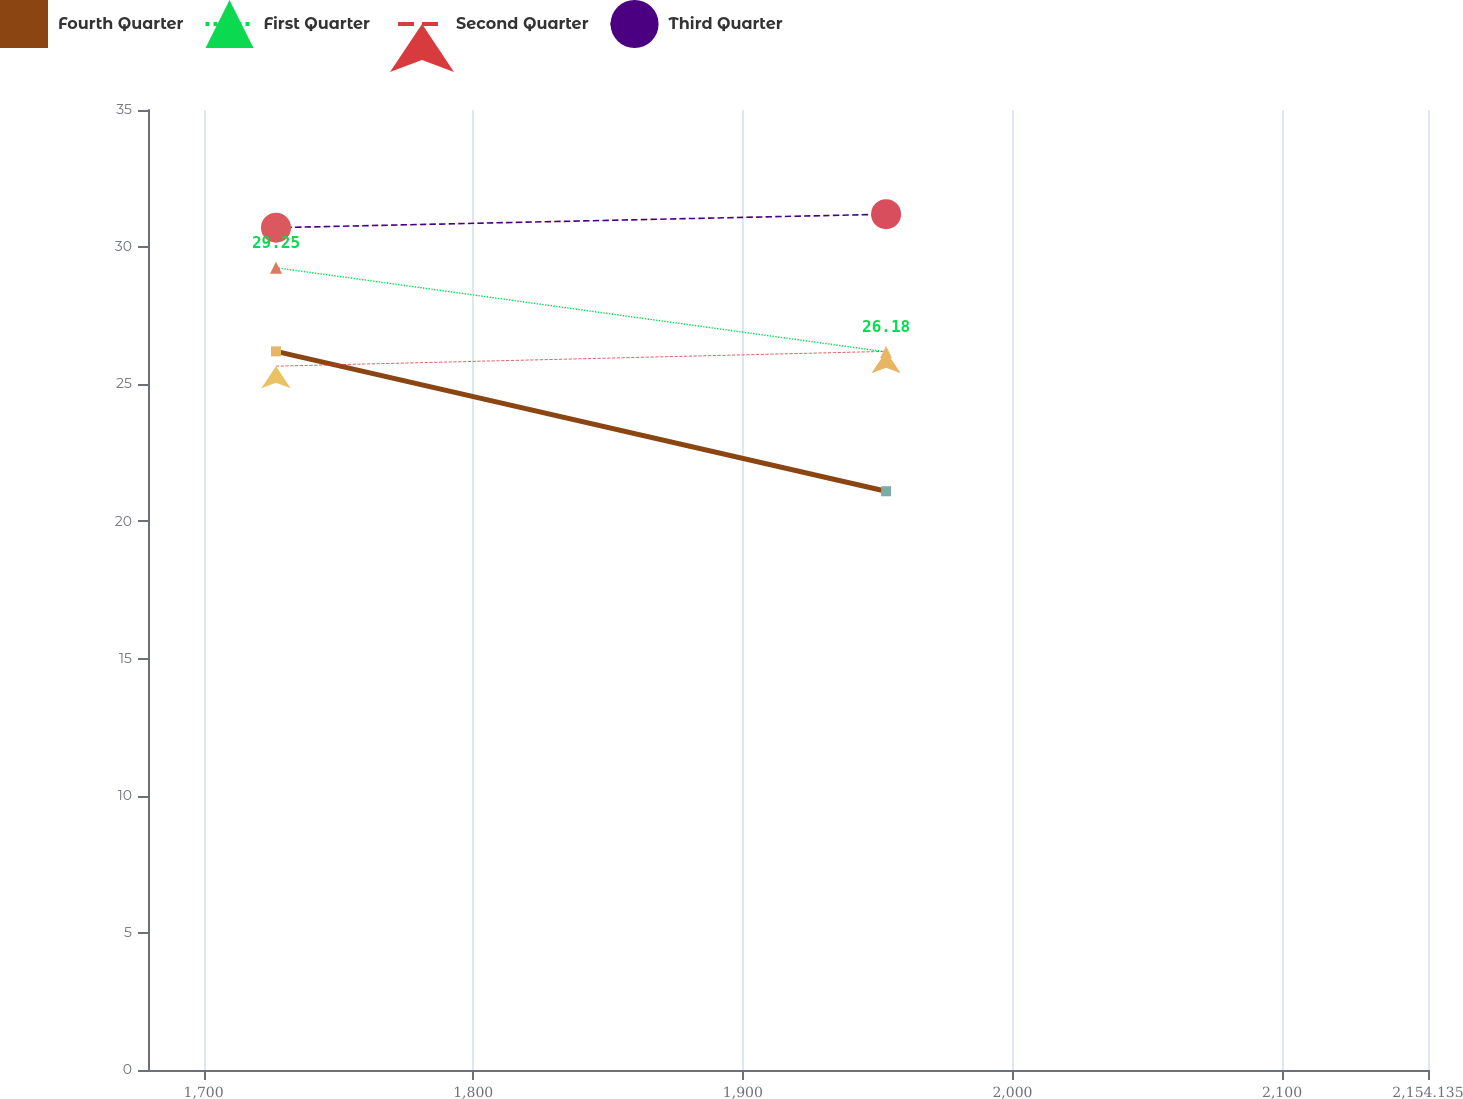Convert chart. <chart><loc_0><loc_0><loc_500><loc_500><line_chart><ecel><fcel>Fourth Quarter<fcel>First Quarter<fcel>Second Quarter<fcel>Third Quarter<nl><fcel>1726.86<fcel>26.2<fcel>29.25<fcel>25.66<fcel>30.71<nl><fcel>1953.14<fcel>21.1<fcel>26.18<fcel>26.2<fcel>31.2<nl><fcel>2201.61<fcel>19.6<fcel>21.98<fcel>25.81<fcel>25.86<nl></chart> 